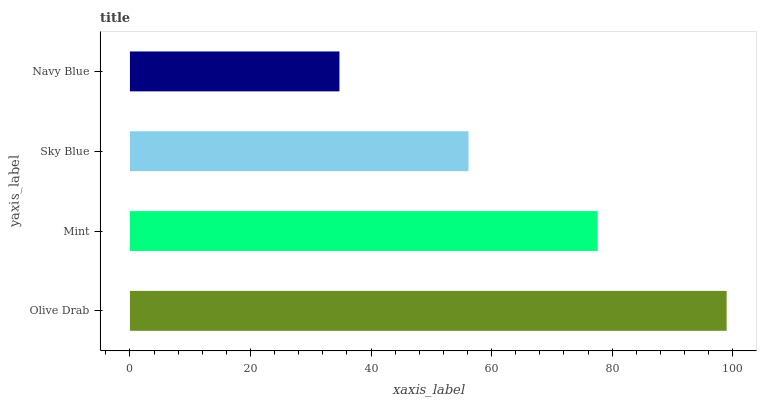Is Navy Blue the minimum?
Answer yes or no. Yes. Is Olive Drab the maximum?
Answer yes or no. Yes. Is Mint the minimum?
Answer yes or no. No. Is Mint the maximum?
Answer yes or no. No. Is Olive Drab greater than Mint?
Answer yes or no. Yes. Is Mint less than Olive Drab?
Answer yes or no. Yes. Is Mint greater than Olive Drab?
Answer yes or no. No. Is Olive Drab less than Mint?
Answer yes or no. No. Is Mint the high median?
Answer yes or no. Yes. Is Sky Blue the low median?
Answer yes or no. Yes. Is Olive Drab the high median?
Answer yes or no. No. Is Mint the low median?
Answer yes or no. No. 